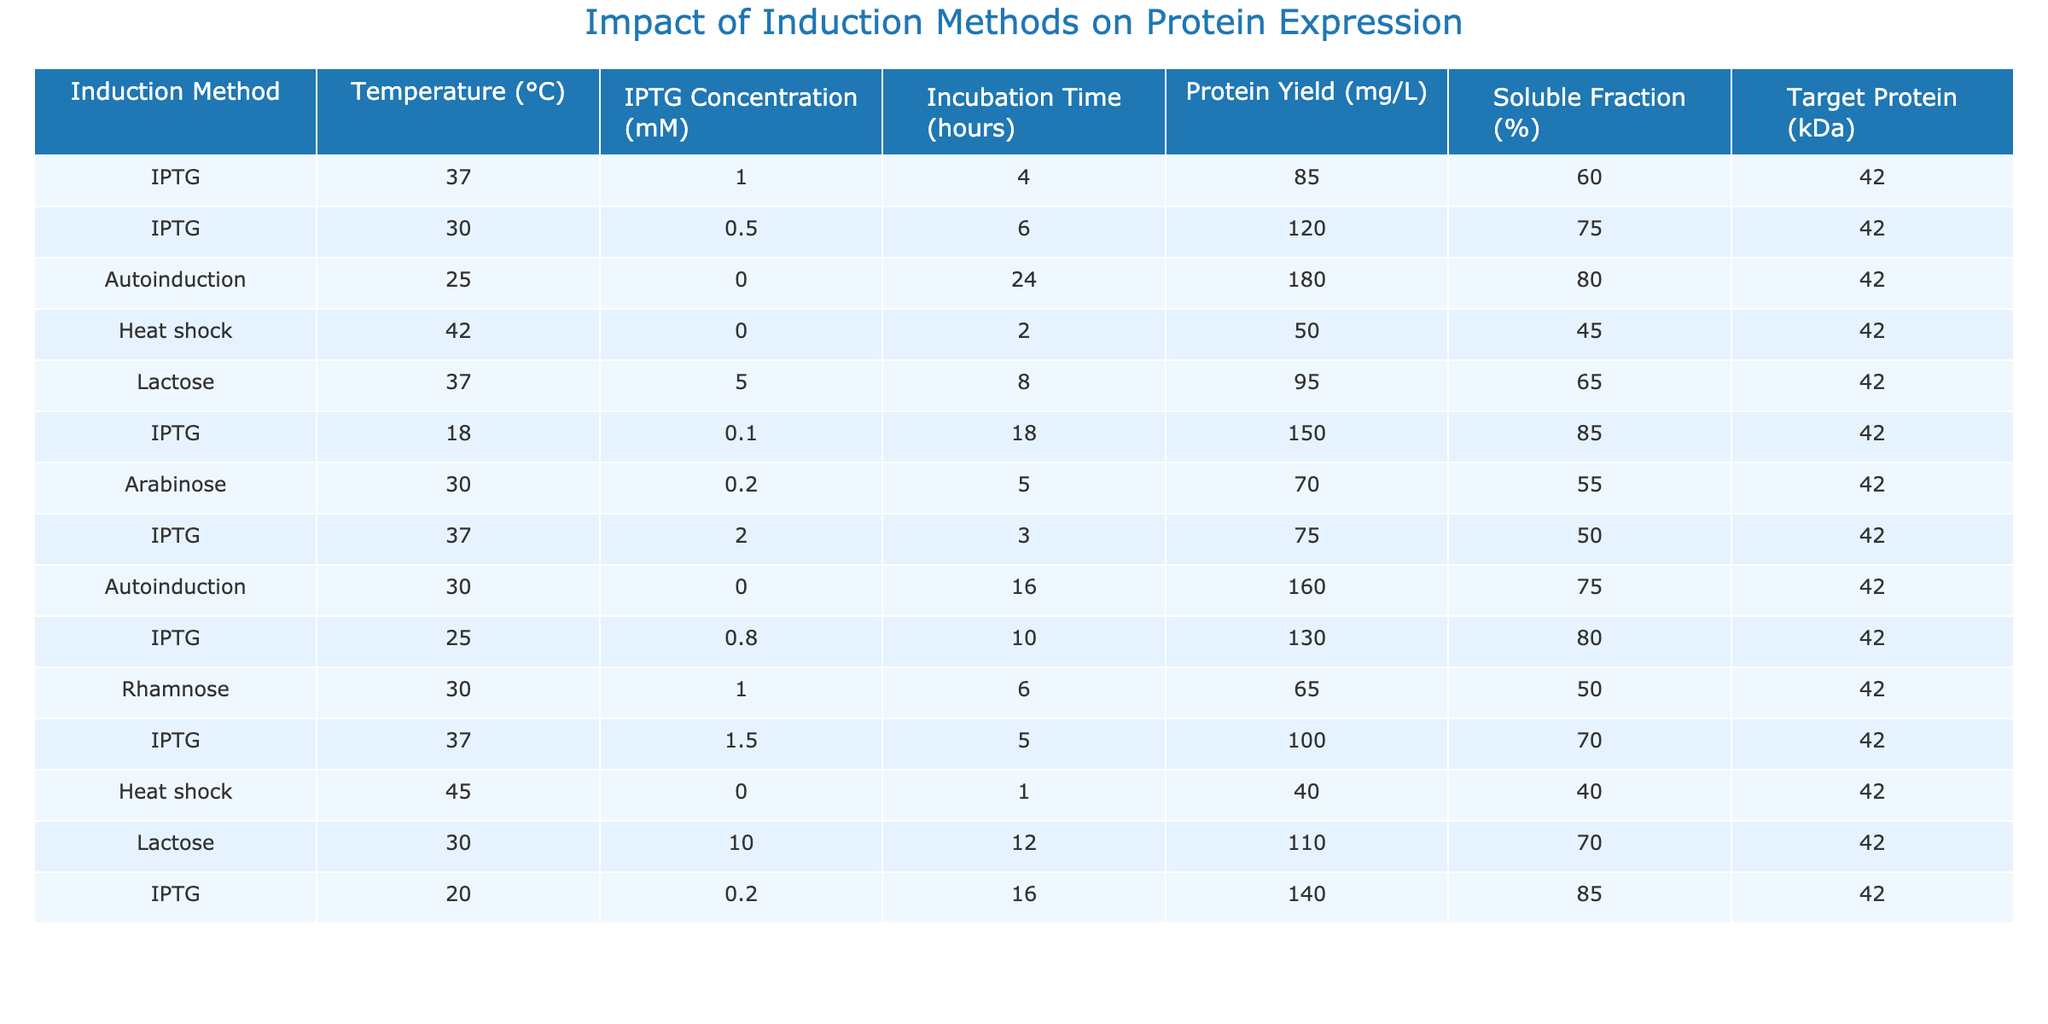What is the protein yield from the autoinduction method at 25 °C? The table shows that the autoinduction method at 25 °C has a protein yield of 180 mg/L.
Answer: 180 mg/L What is the soluble fraction percentage when using IPTG at 30 °C? According to the table, the soluble fraction percentage for IPTG at 30 °C is 75%.
Answer: 75% Which induction method has the highest protein yield? By examining the protein yield column, the autoinduction method at 25 °C yields the highest at 180 mg/L.
Answer: Autoinduction What is the average protein yield across all methods used? To find the average, we sum all the protein yields: (85 + 120 + 180 + 50 + 95 + 150 + 70 + 75 + 130 + 160 + 100 + 40 + 110 + 140) = 1,450 mg/L, then divide by the number of methods (14), giving 1,450 / 14 = 103.57 mg/L.
Answer: 103.57 mg/L Was there any method that resulted in a protein yield greater than 150 mg/L? Yes, both autoinduction at 25 °C (180 mg/L) and IPTG at 18 °C (150 mg/L) had protein yields greater than 150 mg/L.
Answer: Yes How does the protein yield change as the IPTG concentration increases from 1.0 mM to 2.0 mM at 37 °C? At 37 °C, when IPTG concentration increases from 1.0 mM (yield: 85 mg/L) to 1.5 mM (yield: 100 mg/L), the yield increases. However, at 2.0 mM, the yield decreases to 75 mg/L. It first increased to 100 mg/L before dropping to 75 mg/L.
Answer: It first increased, then decreased What is the target protein size for all the induction methods listed? The target protein size for all induction methods listed in the table is consistently 42 kDa.
Answer: 42 kDa What temperature conditions yielded protein yields greater than 100 mg/L? The temperature conditions yielding over 100 mg/L are 30 °C (IPTG at 0.5 mM), 25 °C (autoinduction), and 30 °C (autoinduction). The others yielding above 100 mg/L include 37 °C with several IPTG and lactose instances.
Answer: 25 °C, 30 °C, 37 °C What is the relationship between incubation time and protein yield for IPTG at varying temperatures? Analyzing various IPTG conditions, the yields vary with incubation time; for instance, at 1 mM at 37 °C for 4 hours, the yield is 85 mg/L. Yet, at 30 °C and 0.5 mM over 6 hours, the yield increases to 120 mg/L, indicating a nonlinear relationship influenced also by temperature and concentration.
Answer: Nonlinear relationship Is heat shock a successful method for protein expression based on the table? Heat shock resulted in a protein yield of only 50 mg/L at 42 °C, which is lower compared to many other methods indicated in the table, indicating it's not a successful method in this dataset.
Answer: No 